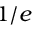<formula> <loc_0><loc_0><loc_500><loc_500>1 / e</formula> 